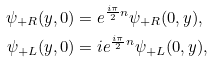Convert formula to latex. <formula><loc_0><loc_0><loc_500><loc_500>\psi _ { + R } ( y , 0 ) & = e ^ { \frac { i \pi } { 2 } n } \psi _ { + R } ( 0 , y ) , \\ \psi _ { + L } ( y , 0 ) & = i e ^ { \frac { i \pi } { 2 } n } \psi _ { + L } ( 0 , y ) ,</formula> 